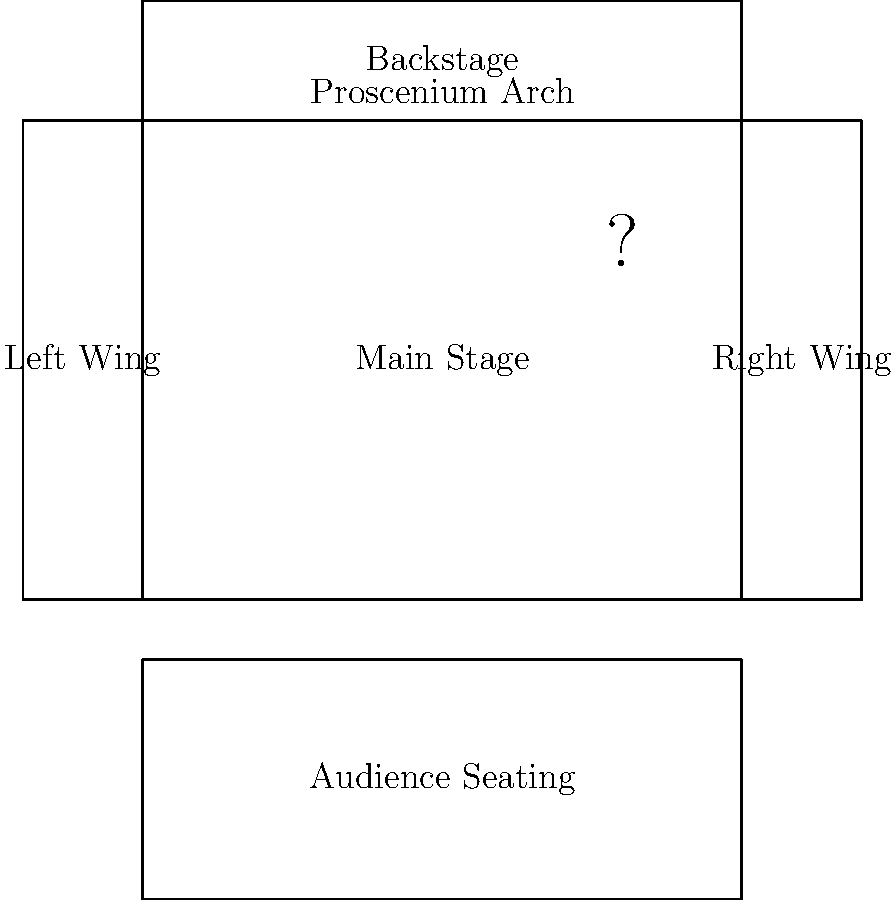In the floor plan of the Abbey Theatre, what is the name of the architectural feature represented by the dashed lines at the front of the stage? To answer this question, let's examine the floor plan of the Abbey Theatre step by step:

1. The main stage area is clearly visible in the center of the diagram.
2. The audience seating is shown at the bottom of the image.
3. On either side of the main stage, we can see the left and right wings.
4. Above the main stage is the backstage area.
5. At the front of the stage, there are two dashed lines drawn vertically.
6. These dashed lines represent a specific architectural feature common in traditional theater designs.
7. This feature is labeled in the diagram as the "Proscenium Arch".

The proscenium arch is a significant element in theater architecture. It acts as a frame for the stage, separating the stage from the auditorium and creating a "window" through which the audience views the performance. This design is particularly important in the Abbey Theatre, as it is known for its traditional proscenium arch stage.
Answer: Proscenium Arch 